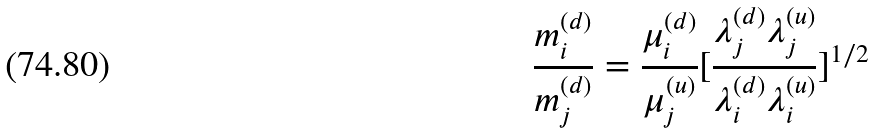Convert formula to latex. <formula><loc_0><loc_0><loc_500><loc_500>\frac { m _ { i } ^ { ( d ) } } { m _ { j } ^ { ( d ) } } = \frac { \mu _ { i } ^ { ( d ) } } { \mu _ { j } ^ { ( u ) } } [ \frac { \lambda _ { j } ^ { ( d ) } \lambda _ { j } ^ { ( u ) } } { \lambda _ { i } ^ { ( d ) } \lambda _ { i } ^ { ( u ) } } ] ^ { 1 / 2 }</formula> 